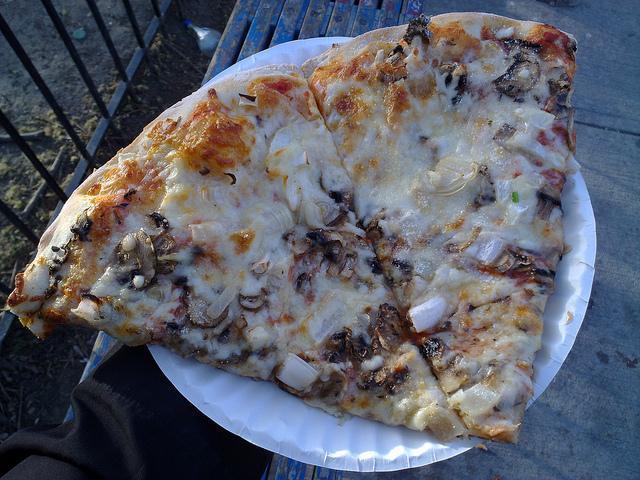How many slices are there?
Give a very brief answer. 2. How many buses are there?
Give a very brief answer. 0. 